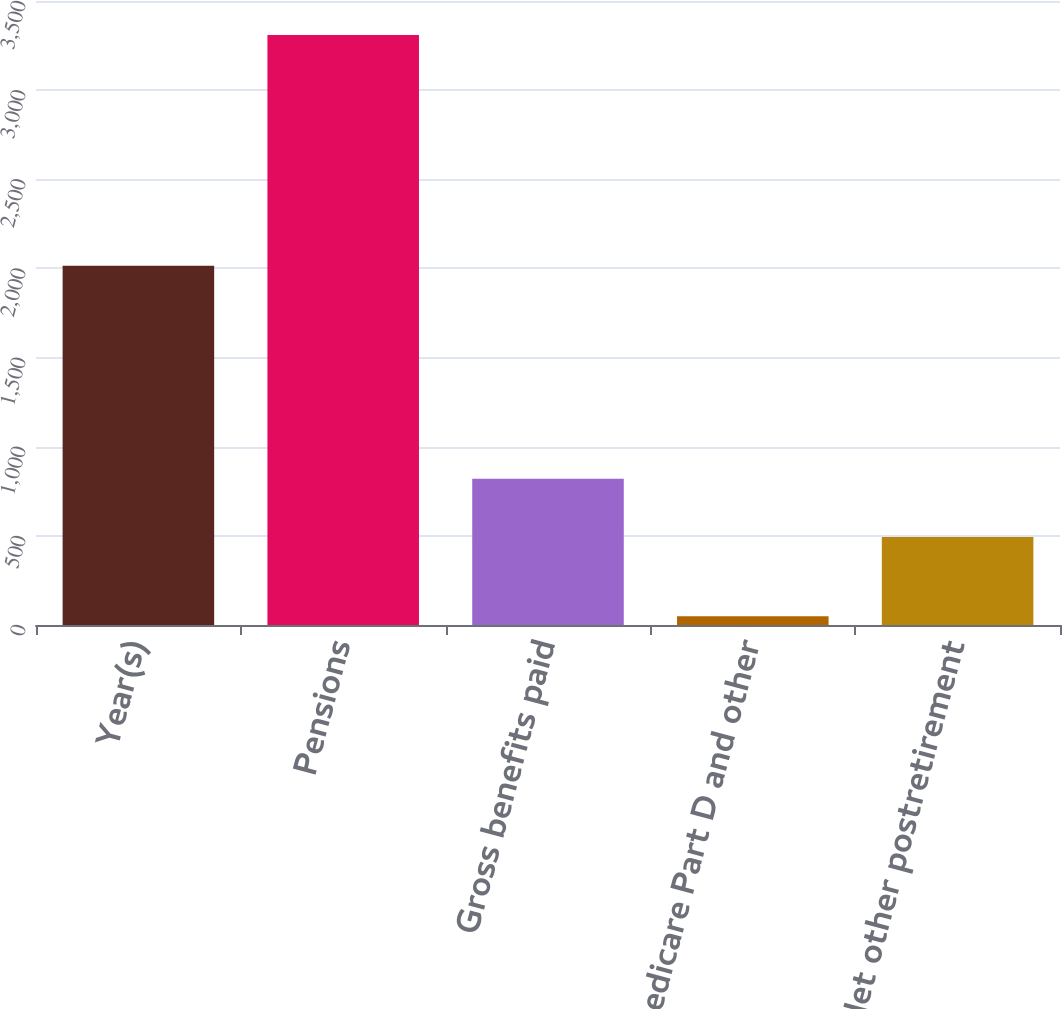Convert chart to OTSL. <chart><loc_0><loc_0><loc_500><loc_500><bar_chart><fcel>Year(s)<fcel>Pensions<fcel>Gross benefits paid<fcel>Medicare Part D and other<fcel>Net other postretirement<nl><fcel>2015<fcel>3309<fcel>820<fcel>49<fcel>494<nl></chart> 